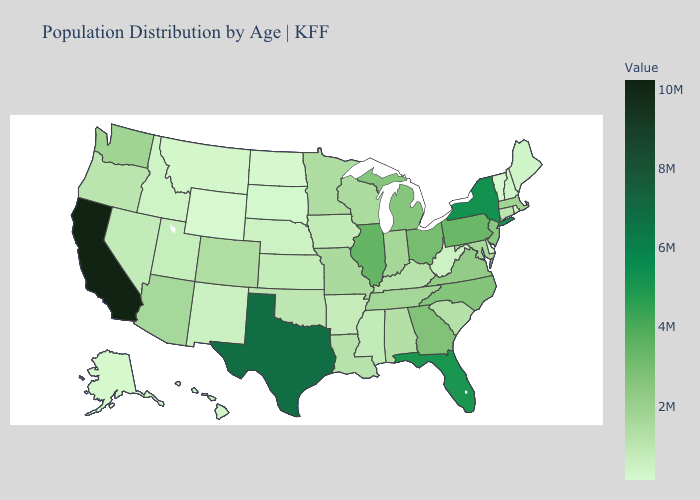Does Illinois have a lower value than New Hampshire?
Give a very brief answer. No. Does the map have missing data?
Answer briefly. No. Among the states that border Texas , which have the lowest value?
Short answer required. New Mexico. Among the states that border Oklahoma , which have the lowest value?
Be succinct. New Mexico. 